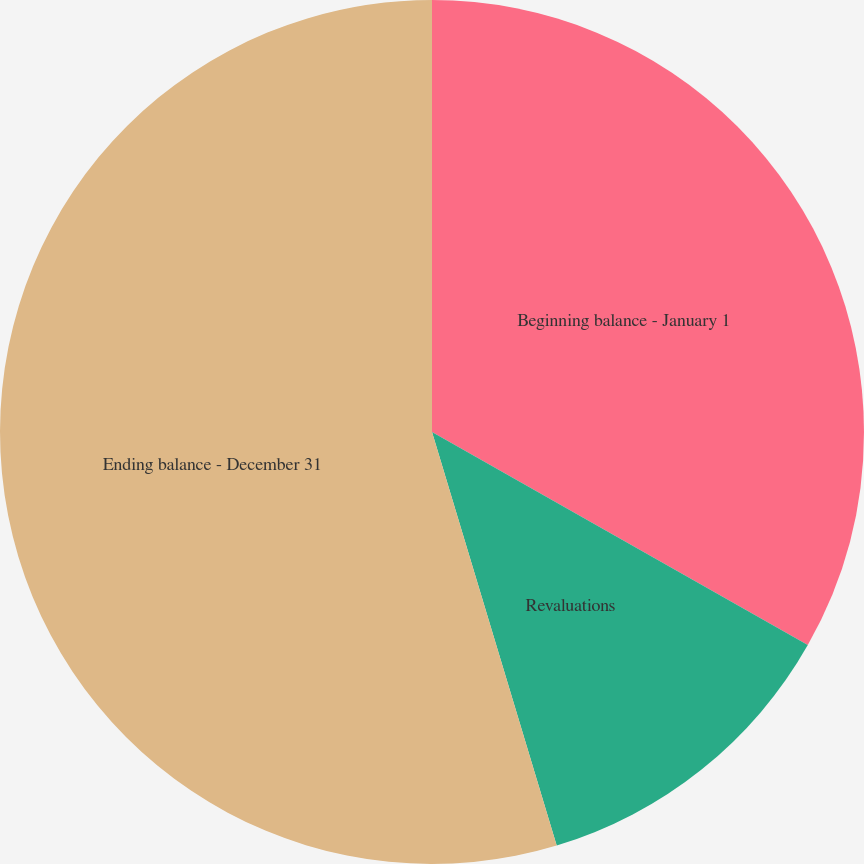<chart> <loc_0><loc_0><loc_500><loc_500><pie_chart><fcel>Beginning balance - January 1<fcel>Revaluations<fcel>Ending balance - December 31<nl><fcel>33.21%<fcel>12.13%<fcel>54.66%<nl></chart> 